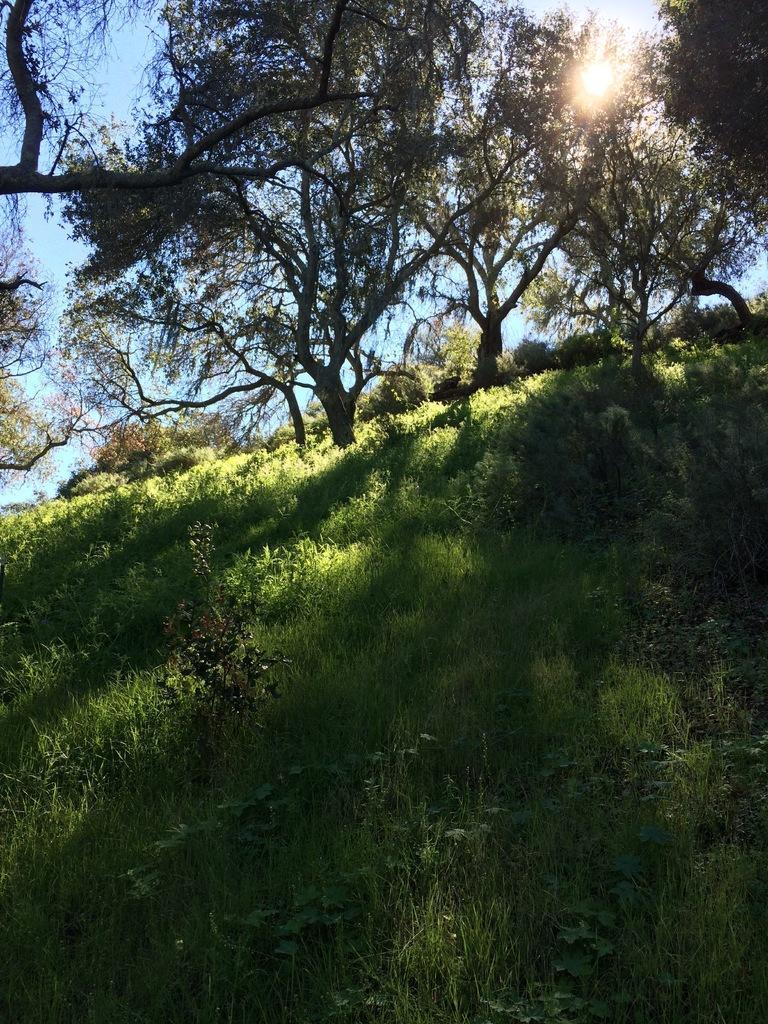How would you summarize this image in a sentence or two? In this image we can see a group of trees, plants and the grass. At the top we can see the sun in the sky. 